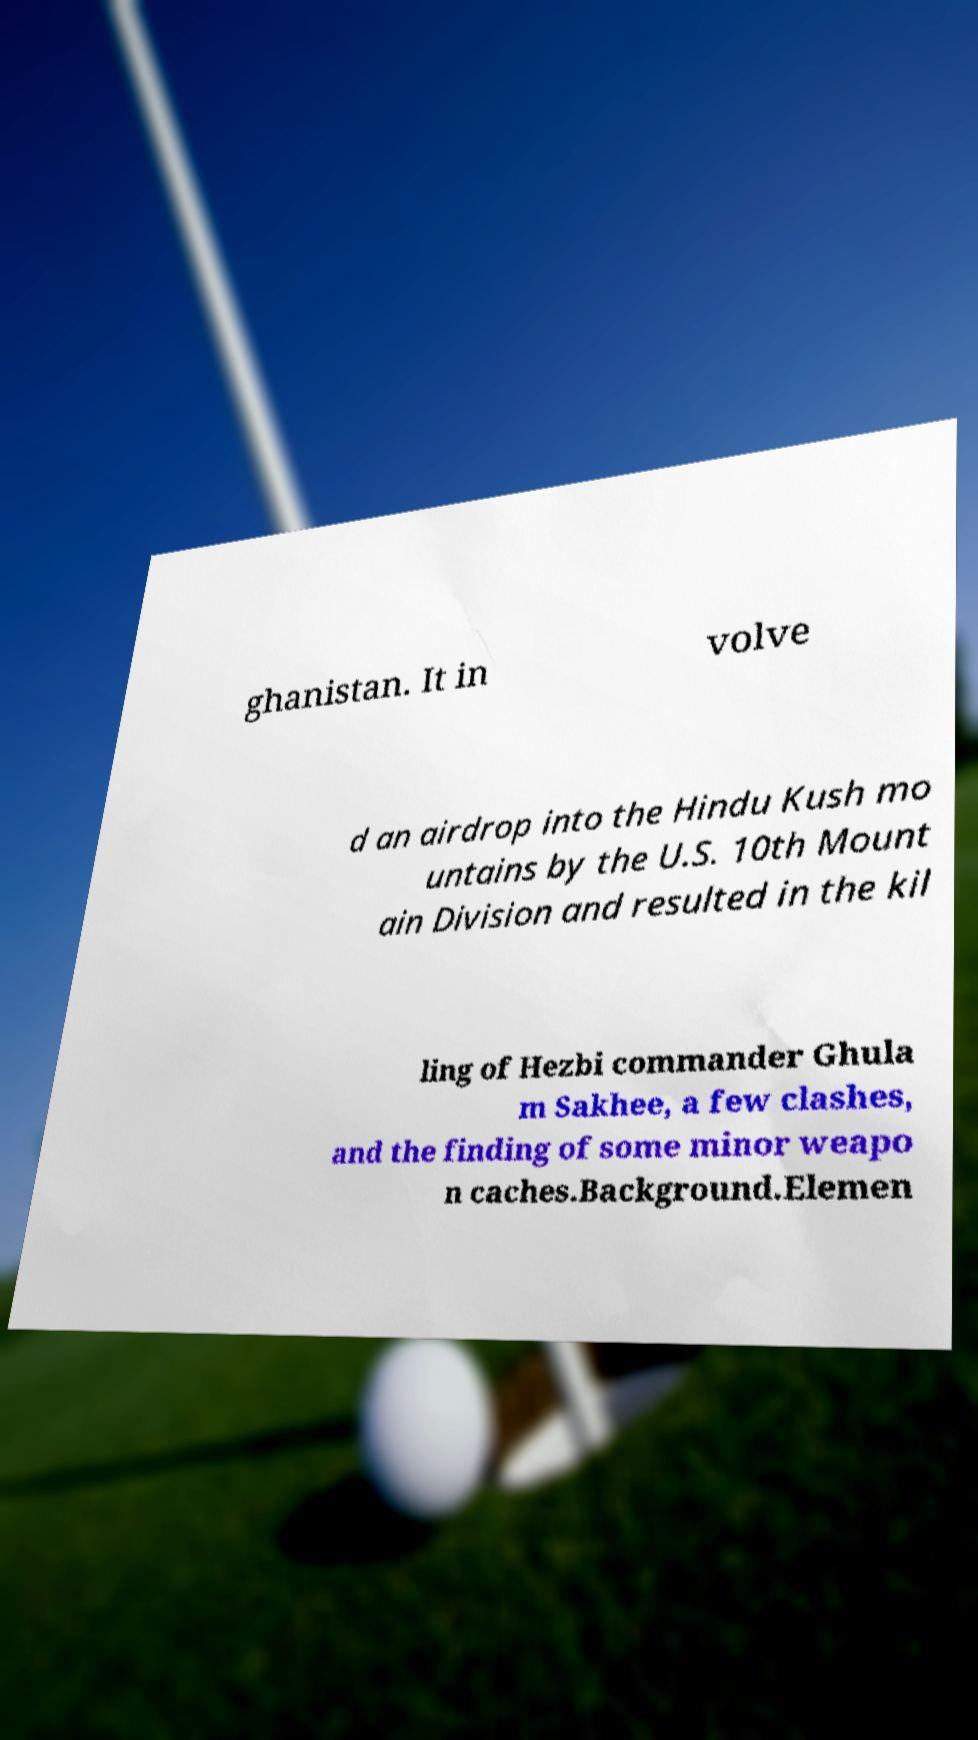Can you read and provide the text displayed in the image?This photo seems to have some interesting text. Can you extract and type it out for me? ghanistan. It in volve d an airdrop into the Hindu Kush mo untains by the U.S. 10th Mount ain Division and resulted in the kil ling of Hezbi commander Ghula m Sakhee, a few clashes, and the finding of some minor weapo n caches.Background.Elemen 